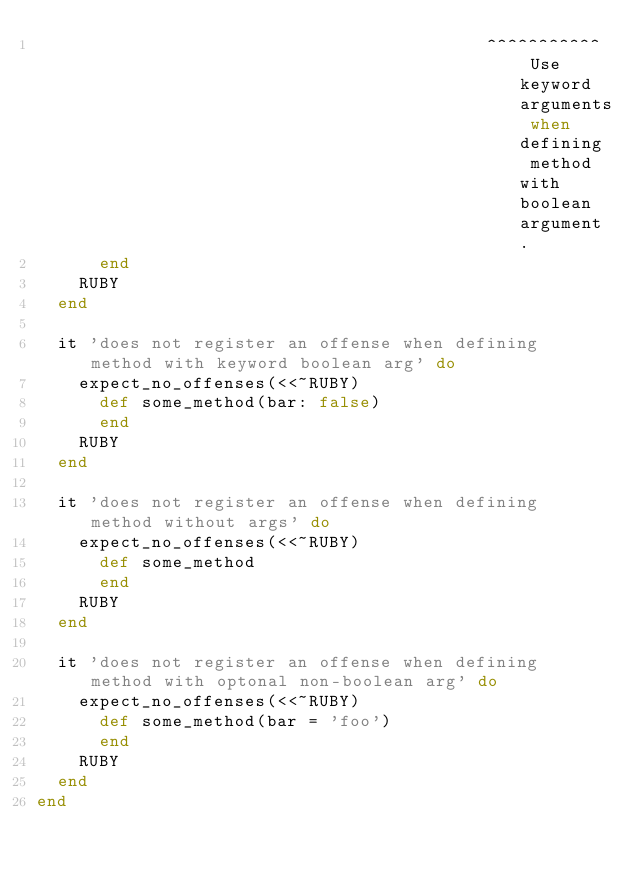Convert code to text. <code><loc_0><loc_0><loc_500><loc_500><_Ruby_>                                           ^^^^^^^^^^^ Use keyword arguments when defining method with boolean argument.
      end
    RUBY
  end

  it 'does not register an offense when defining method with keyword boolean arg' do
    expect_no_offenses(<<~RUBY)
      def some_method(bar: false)
      end
    RUBY
  end

  it 'does not register an offense when defining method without args' do
    expect_no_offenses(<<~RUBY)
      def some_method
      end
    RUBY
  end

  it 'does not register an offense when defining method with optonal non-boolean arg' do
    expect_no_offenses(<<~RUBY)
      def some_method(bar = 'foo')
      end
    RUBY
  end
end
</code> 